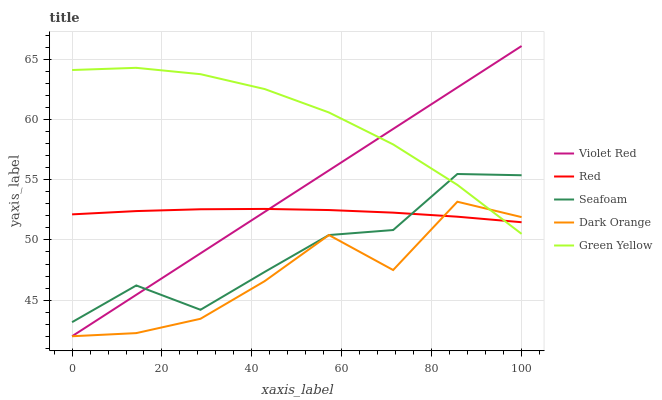Does Dark Orange have the minimum area under the curve?
Answer yes or no. Yes. Does Green Yellow have the maximum area under the curve?
Answer yes or no. Yes. Does Violet Red have the minimum area under the curve?
Answer yes or no. No. Does Violet Red have the maximum area under the curve?
Answer yes or no. No. Is Violet Red the smoothest?
Answer yes or no. Yes. Is Dark Orange the roughest?
Answer yes or no. Yes. Is Green Yellow the smoothest?
Answer yes or no. No. Is Green Yellow the roughest?
Answer yes or no. No. Does Dark Orange have the lowest value?
Answer yes or no. Yes. Does Green Yellow have the lowest value?
Answer yes or no. No. Does Violet Red have the highest value?
Answer yes or no. Yes. Does Green Yellow have the highest value?
Answer yes or no. No. Is Dark Orange less than Seafoam?
Answer yes or no. Yes. Is Seafoam greater than Dark Orange?
Answer yes or no. Yes. Does Seafoam intersect Violet Red?
Answer yes or no. Yes. Is Seafoam less than Violet Red?
Answer yes or no. No. Is Seafoam greater than Violet Red?
Answer yes or no. No. Does Dark Orange intersect Seafoam?
Answer yes or no. No. 